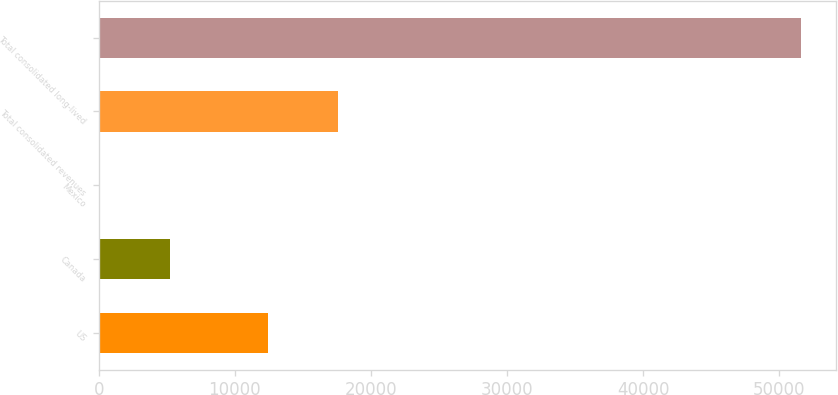<chart> <loc_0><loc_0><loc_500><loc_500><bar_chart><fcel>US<fcel>Canada<fcel>Mexico<fcel>Total consolidated revenues<fcel>Total consolidated long-lived<nl><fcel>12459<fcel>5265<fcel>116<fcel>17608<fcel>51606<nl></chart> 